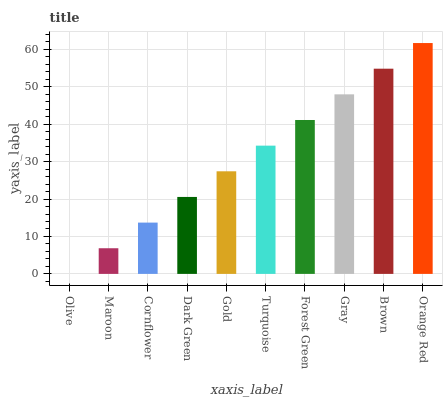Is Olive the minimum?
Answer yes or no. Yes. Is Orange Red the maximum?
Answer yes or no. Yes. Is Maroon the minimum?
Answer yes or no. No. Is Maroon the maximum?
Answer yes or no. No. Is Maroon greater than Olive?
Answer yes or no. Yes. Is Olive less than Maroon?
Answer yes or no. Yes. Is Olive greater than Maroon?
Answer yes or no. No. Is Maroon less than Olive?
Answer yes or no. No. Is Turquoise the high median?
Answer yes or no. Yes. Is Gold the low median?
Answer yes or no. Yes. Is Olive the high median?
Answer yes or no. No. Is Turquoise the low median?
Answer yes or no. No. 